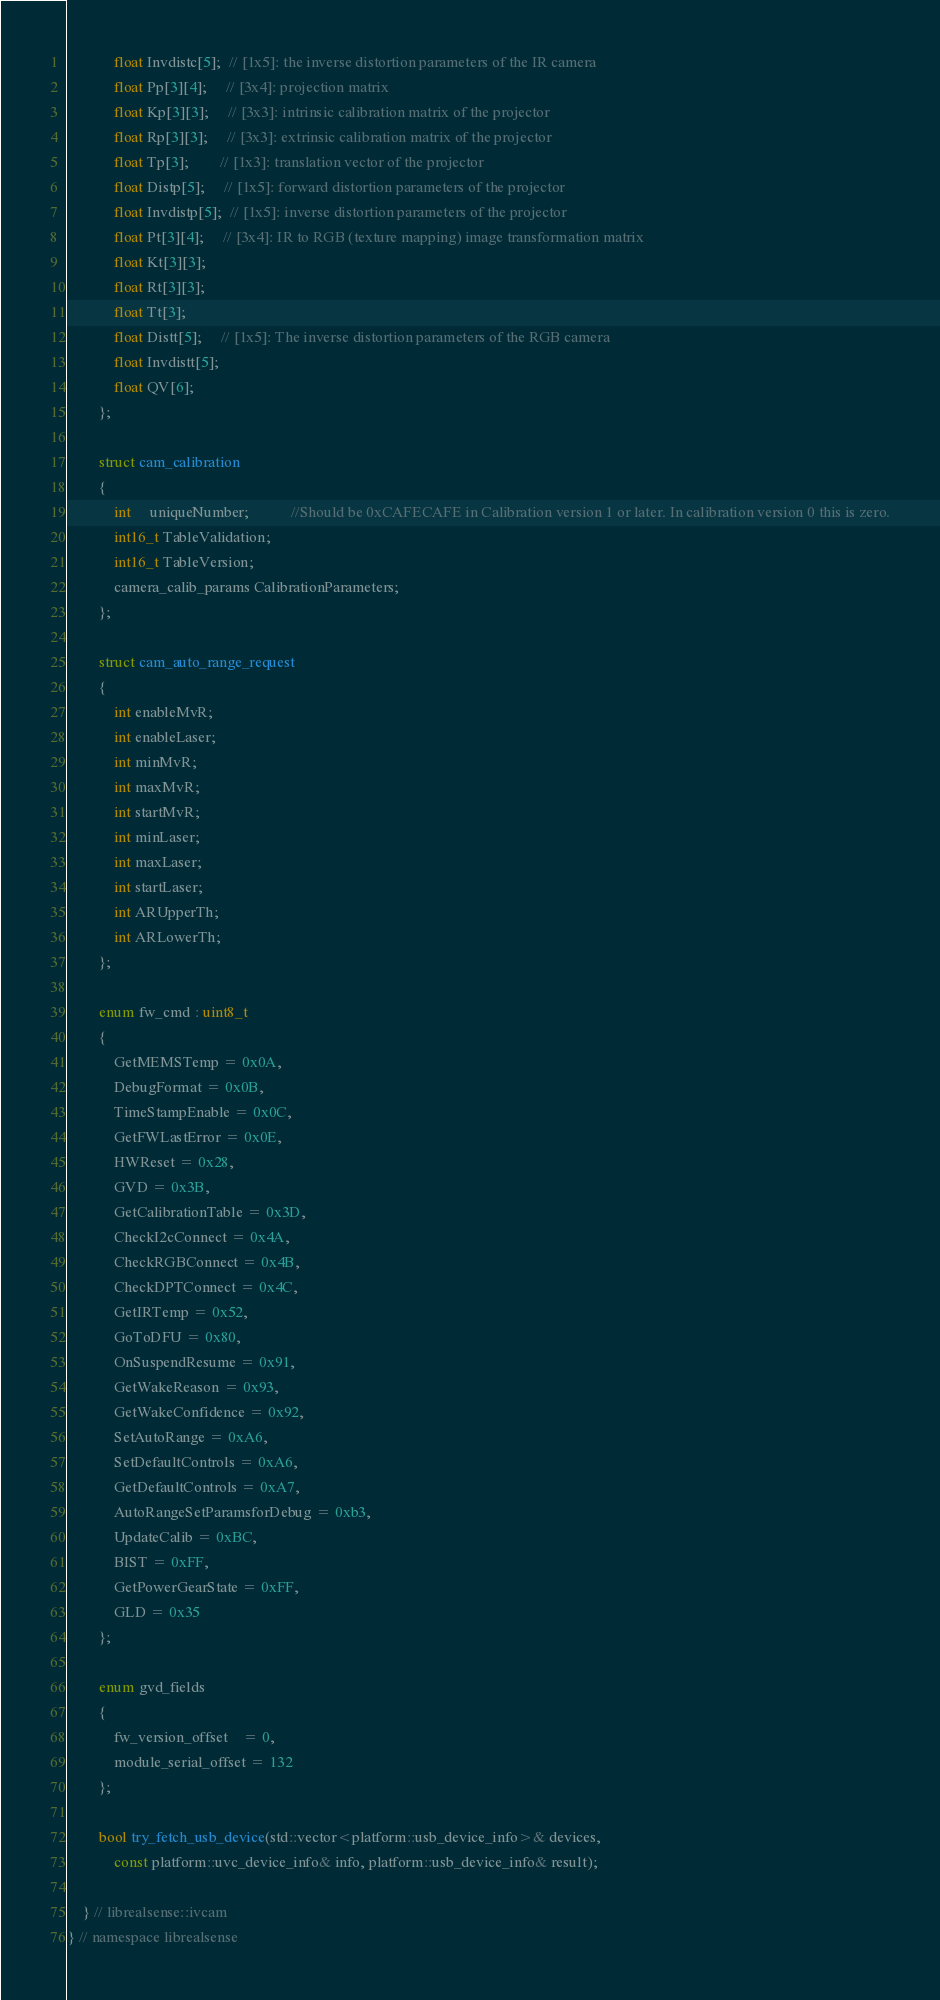<code> <loc_0><loc_0><loc_500><loc_500><_C_>            float Invdistc[5];  // [1x5]: the inverse distortion parameters of the IR camera
            float Pp[3][4];     // [3x4]: projection matrix
            float Kp[3][3];     // [3x3]: intrinsic calibration matrix of the projector
            float Rp[3][3];     // [3x3]: extrinsic calibration matrix of the projector
            float Tp[3];        // [1x3]: translation vector of the projector
            float Distp[5];     // [1x5]: forward distortion parameters of the projector
            float Invdistp[5];  // [1x5]: inverse distortion parameters of the projector
            float Pt[3][4];     // [3x4]: IR to RGB (texture mapping) image transformation matrix
            float Kt[3][3];
            float Rt[3][3];
            float Tt[3];
            float Distt[5];     // [1x5]: The inverse distortion parameters of the RGB camera
            float Invdistt[5];
            float QV[6];
        };

        struct cam_calibration
        {
            int     uniqueNumber;           //Should be 0xCAFECAFE in Calibration version 1 or later. In calibration version 0 this is zero.
            int16_t TableValidation;
            int16_t TableVersion;
            camera_calib_params CalibrationParameters;
        };

        struct cam_auto_range_request
        {
            int enableMvR;
            int enableLaser;
            int minMvR;
            int maxMvR;
            int startMvR;
            int minLaser;
            int maxLaser;
            int startLaser;
            int ARUpperTh;
            int ARLowerTh;
        };

        enum fw_cmd : uint8_t
        {
            GetMEMSTemp = 0x0A,
            DebugFormat = 0x0B,
            TimeStampEnable = 0x0C,
            GetFWLastError = 0x0E,
            HWReset = 0x28,
            GVD = 0x3B,
            GetCalibrationTable = 0x3D,
            CheckI2cConnect = 0x4A,
            CheckRGBConnect = 0x4B,
            CheckDPTConnect = 0x4C,
            GetIRTemp = 0x52,
            GoToDFU = 0x80,
            OnSuspendResume = 0x91,
            GetWakeReason = 0x93,
            GetWakeConfidence = 0x92,
            SetAutoRange = 0xA6,
            SetDefaultControls = 0xA6,
            GetDefaultControls = 0xA7,
            AutoRangeSetParamsforDebug = 0xb3,
            UpdateCalib = 0xBC,
            BIST = 0xFF,
            GetPowerGearState = 0xFF,
            GLD = 0x35
        };

        enum gvd_fields
        {
            fw_version_offset    = 0,
            module_serial_offset = 132
        };

        bool try_fetch_usb_device(std::vector<platform::usb_device_info>& devices,
            const platform::uvc_device_info& info, platform::usb_device_info& result);

    } // librealsense::ivcam
} // namespace librealsense
</code> 